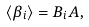<formula> <loc_0><loc_0><loc_500><loc_500>\langle \beta _ { i } \rangle = B _ { i } A ,</formula> 